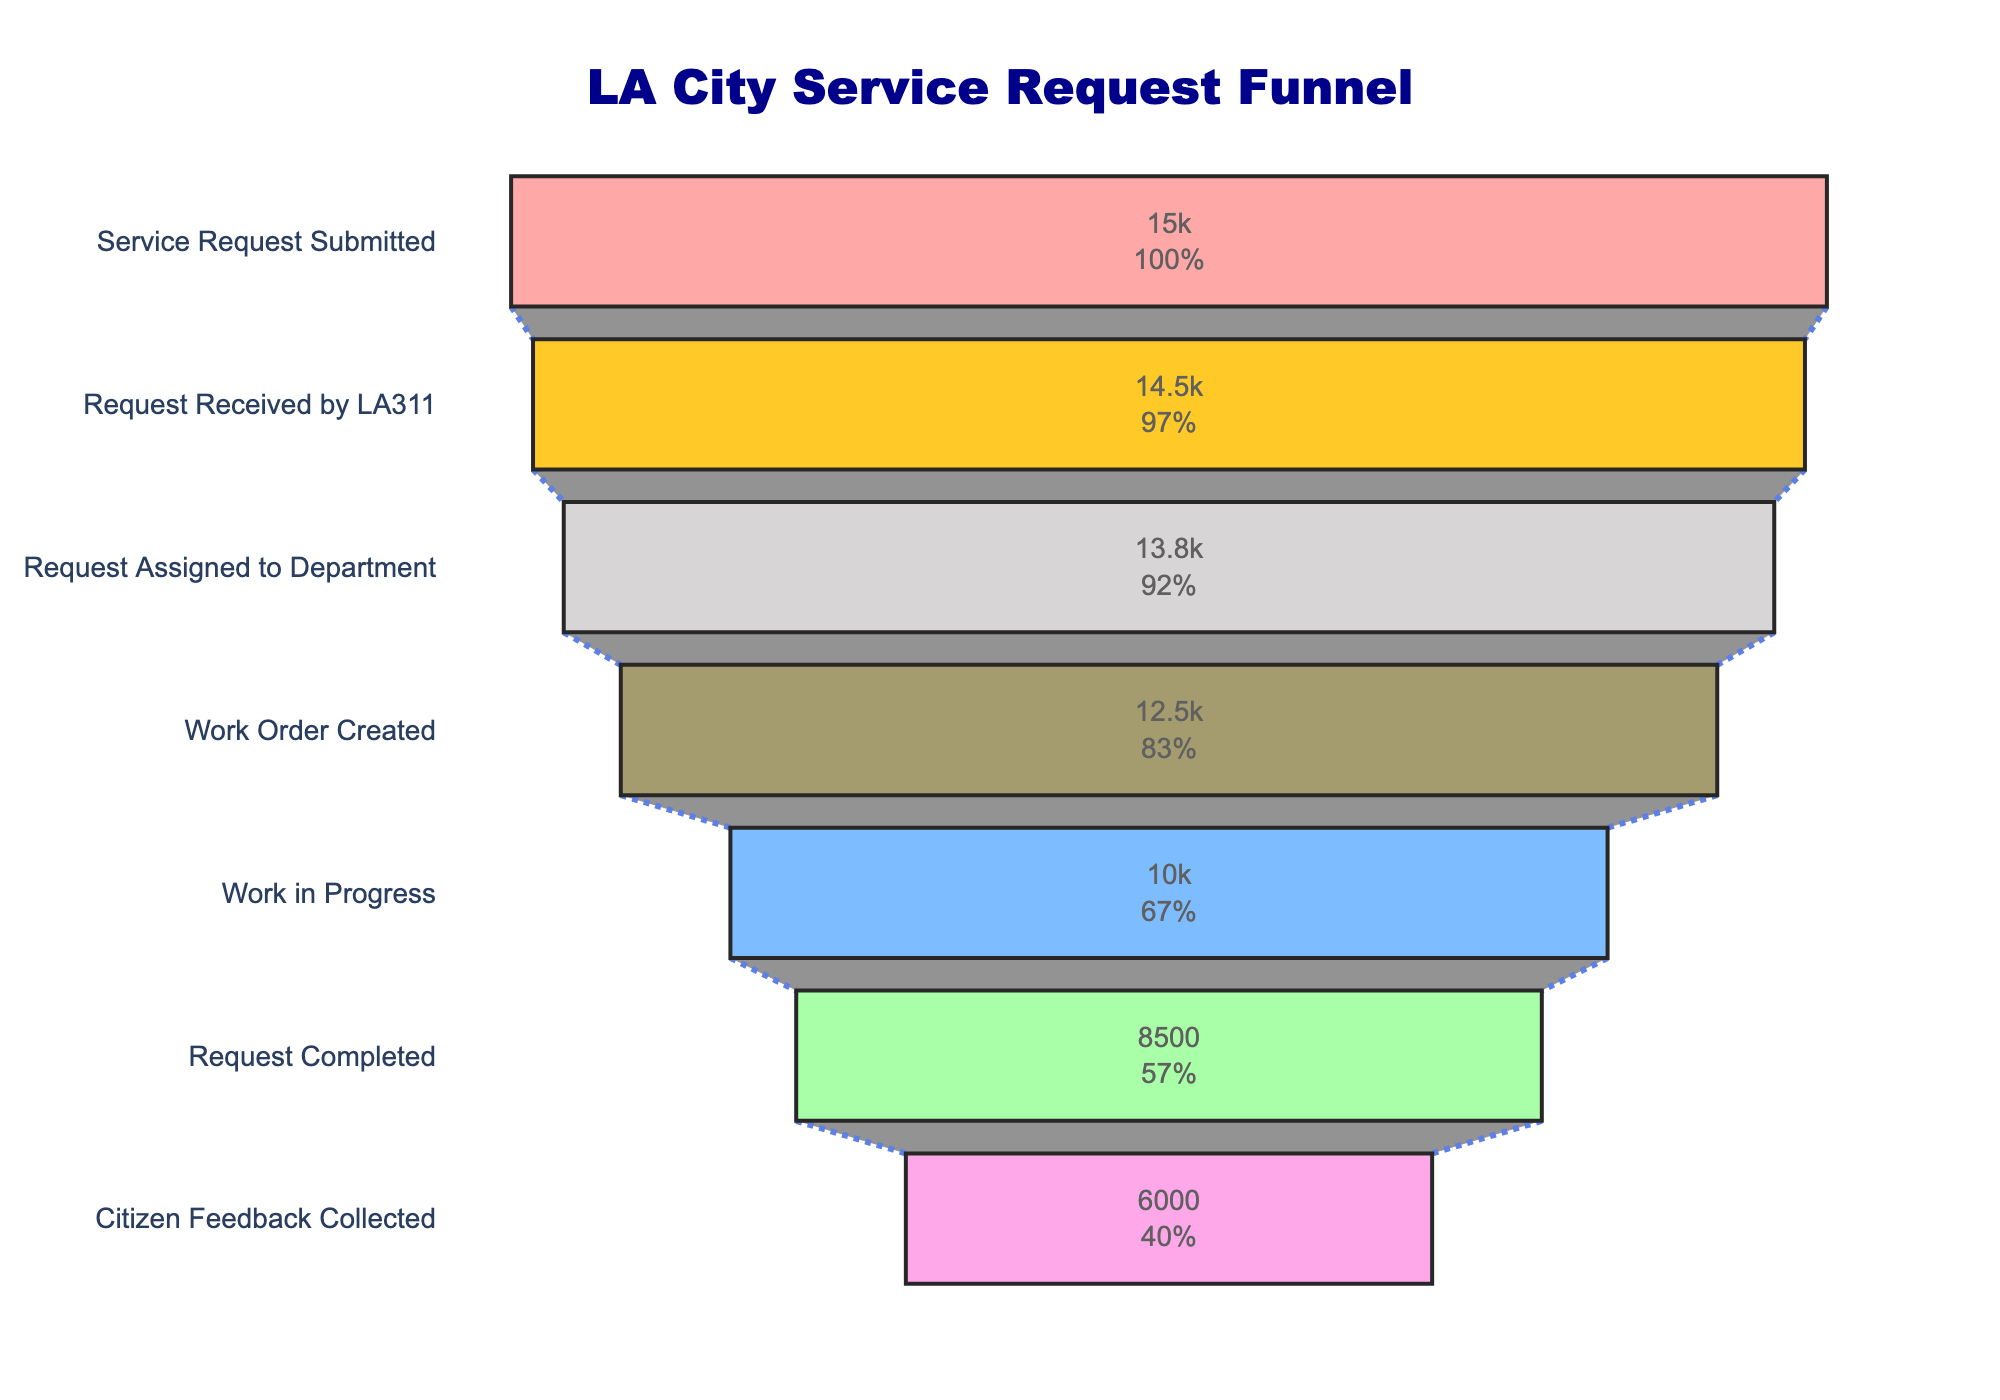What is the title of the chart? The title is often found at the top of the chart, providing a clear indication of what the chart represents. In this case, it's centered at the top.
Answer: LA City Service Request Funnel How many stages are there in the funnel? To determine the number of stages, count the distinct labels listed vertically in the chart.
Answer: 7 What is the count for the 'Work Order Created' stage? Locate the 'Work Order Created' stage and read the count value displayed inside the bar.
Answer: 12500 What stage has the lowest count? Compare the counts of all stages and identify the one with the smallest value.
Answer: Citizen Feedback Collected Which stage has a count closest to 10,000? Look at the counts of each stage and find the one that is numerically closest to 10,000.
Answer: Work in Progress How many requests are lost between the 'Request Assigned to Department' and 'Work Order Created' stages? Subtract the count of 'Work Order Created' from 'Request Assigned to Department': 13800 - 12500
Answer: 1300 What is the percentage decrease from 'Work in Progress' to 'Request Completed'? Calculate the percentage decrease using the counts of those stages: ((10000 - 8500) / 10000) * 100%
Answer: 15% Which two consecutive stages have the smallest difference in counts? Compare the differences in counts between each pair of consecutive stages and identify the smallest one. 14500 - 15000, 14500 - 13800, 13800 - 12500, 12500 - 10000, 10000 - 8500, 8500 - 6000.
Answer: Service Request Submitted to Request Received by LA311 (500) What percentage of the total submitted requests result in citizen feedback collected? Calculate this by dividing the count of 'Citizen Feedback Collected' by 'Service Request Submitted' and converting to a percentage: (6000 / 15000) * 100%
Answer: 40% How many more requests were completed compared to the number of work orders created? Subtract the count of 'Request Completed' from 'Work Order Created': 12500 - 8500
Answer: 4000 